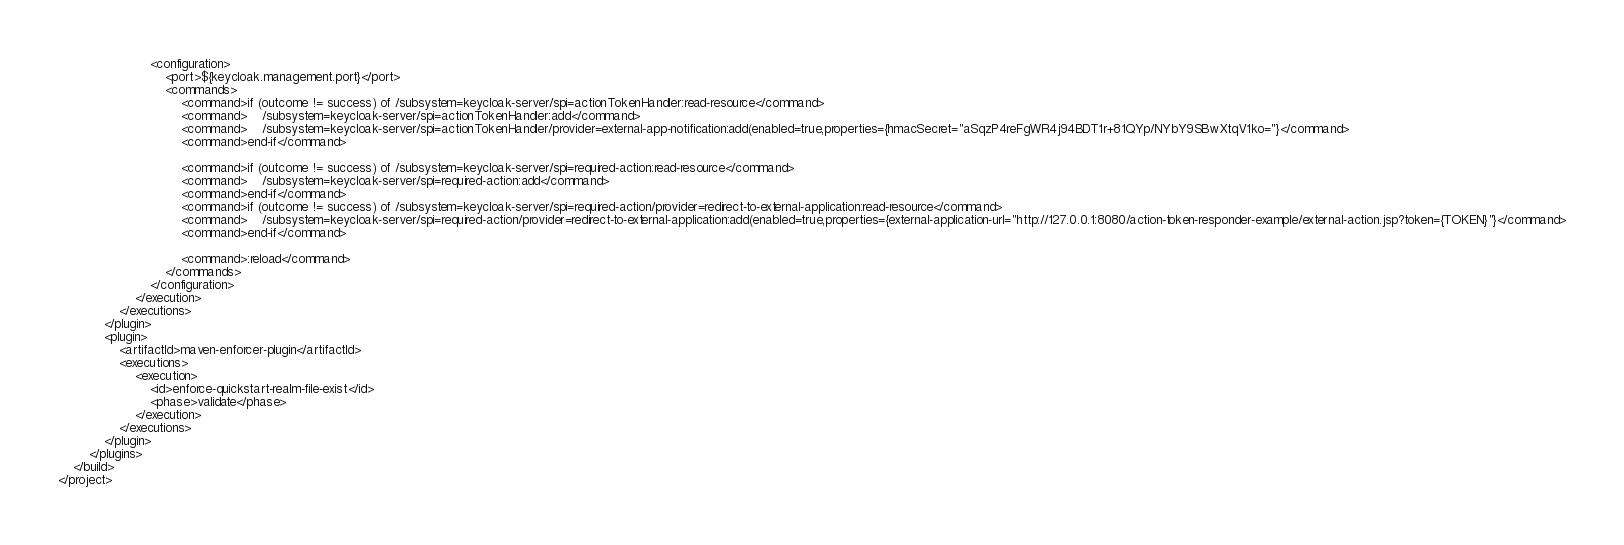Convert code to text. <code><loc_0><loc_0><loc_500><loc_500><_XML_>                        <configuration>
                            <port>${keycloak.management.port}</port>
                            <commands>
                                <command>if (outcome != success) of /subsystem=keycloak-server/spi=actionTokenHandler:read-resource</command>
                                <command>    /subsystem=keycloak-server/spi=actionTokenHandler:add</command>
                                <command>    /subsystem=keycloak-server/spi=actionTokenHandler/provider=external-app-notification:add(enabled=true,properties={hmacSecret="aSqzP4reFgWR4j94BDT1r+81QYp/NYbY9SBwXtqV1ko="}</command>
                                <command>end-if</command>

                                <command>if (outcome != success) of /subsystem=keycloak-server/spi=required-action:read-resource</command>
                                <command>    /subsystem=keycloak-server/spi=required-action:add</command>
                                <command>end-if</command>
                                <command>if (outcome != success) of /subsystem=keycloak-server/spi=required-action/provider=redirect-to-external-application:read-resource</command>
                                <command>    /subsystem=keycloak-server/spi=required-action/provider=redirect-to-external-application:add(enabled=true,properties={external-application-url="http://127.0.0.1:8080/action-token-responder-example/external-action.jsp?token={TOKEN}"}</command>
                                <command>end-if</command>

                                <command>:reload</command>
                            </commands>
                        </configuration>
                    </execution>
                </executions>
            </plugin>
            <plugin>
                <artifactId>maven-enforcer-plugin</artifactId>
                <executions>
                    <execution>
                        <id>enforce-quickstart-realm-file-exist</id>
                        <phase>validate</phase>
                    </execution>
                </executions>
            </plugin>
        </plugins>
    </build>
</project>
</code> 